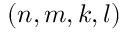<formula> <loc_0><loc_0><loc_500><loc_500>( n , m , k , l )</formula> 